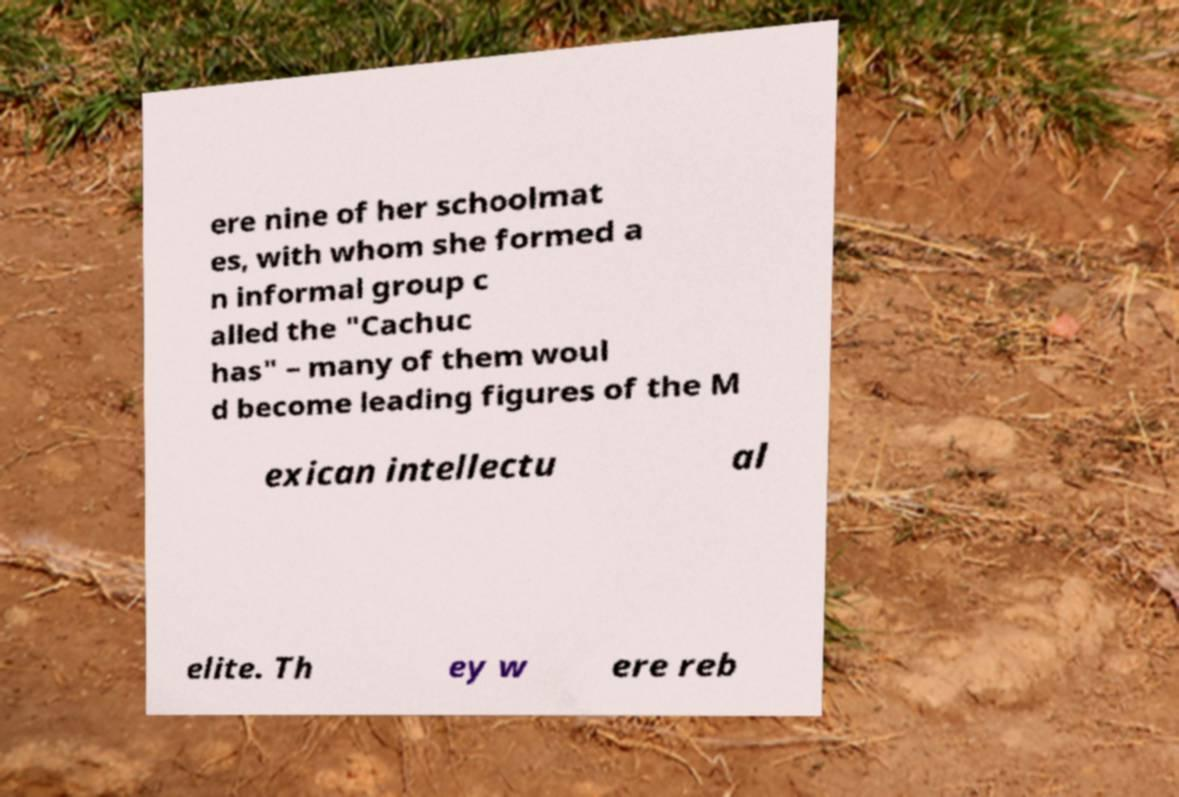Could you assist in decoding the text presented in this image and type it out clearly? ere nine of her schoolmat es, with whom she formed a n informal group c alled the "Cachuc has" – many of them woul d become leading figures of the M exican intellectu al elite. Th ey w ere reb 